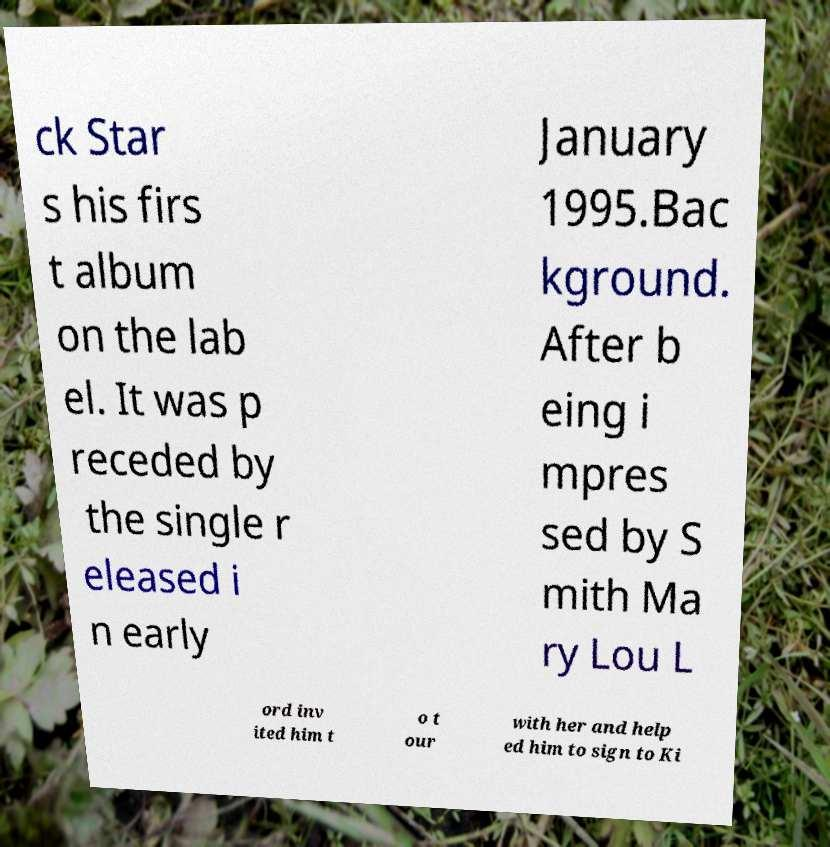What messages or text are displayed in this image? I need them in a readable, typed format. ck Star s his firs t album on the lab el. It was p receded by the single r eleased i n early January 1995.Bac kground. After b eing i mpres sed by S mith Ma ry Lou L ord inv ited him t o t our with her and help ed him to sign to Ki 